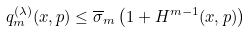Convert formula to latex. <formula><loc_0><loc_0><loc_500><loc_500>q ^ { ( \lambda ) } _ { m } ( x , p ) \leq \overline { \sigma } _ { m } \left ( 1 + H ^ { m - 1 } ( x , p ) \right )</formula> 